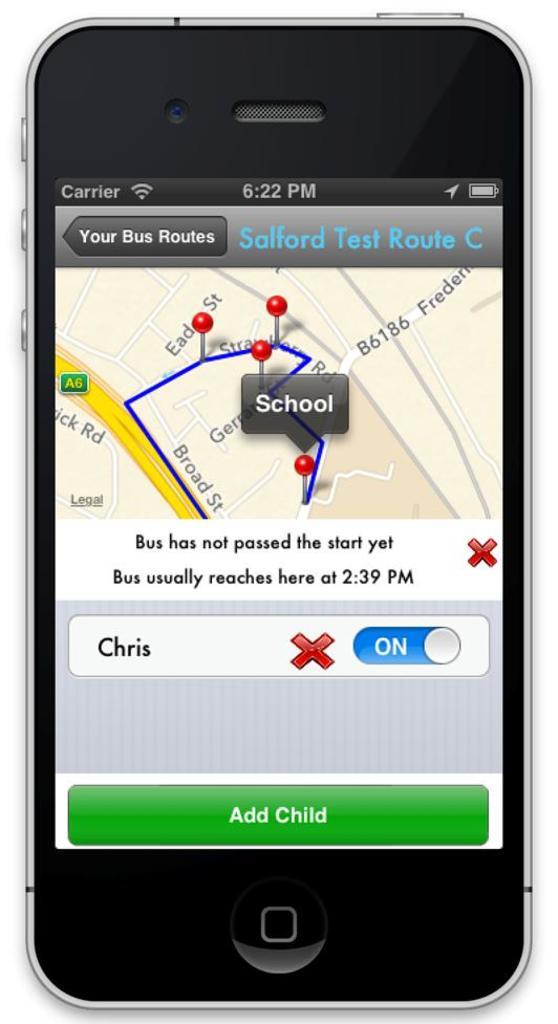What is the bottom green button labeled?
Offer a very short reply. Add child. What time is it on the phone?
Provide a short and direct response. 6:22pm. 